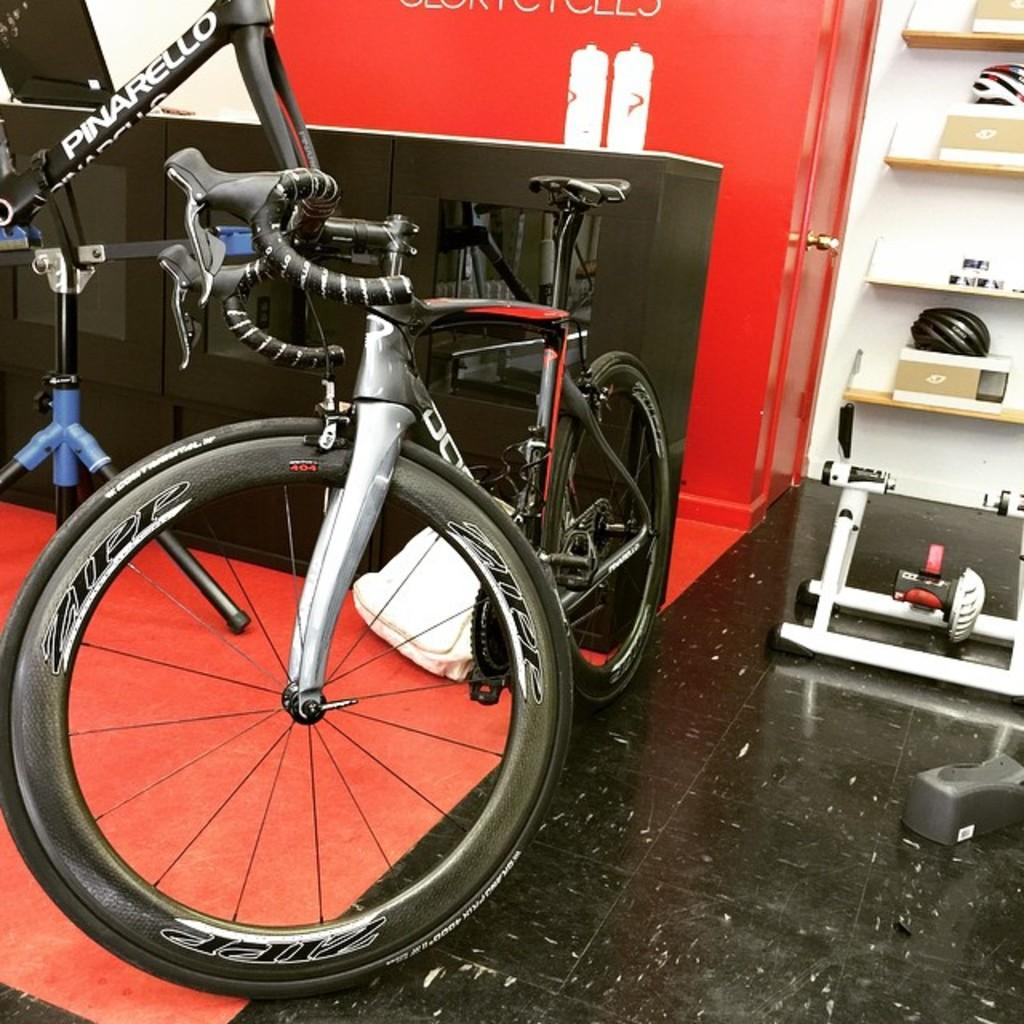What is located on the ground in the image? There is a machine on the ground in the image. What can be seen on the left side of the image? There is a bicycle on the left side of the image. Where is the zipper located in the image? There is no zipper present in the image. What type of boat can be seen in the image? There is no boat present in the image. 